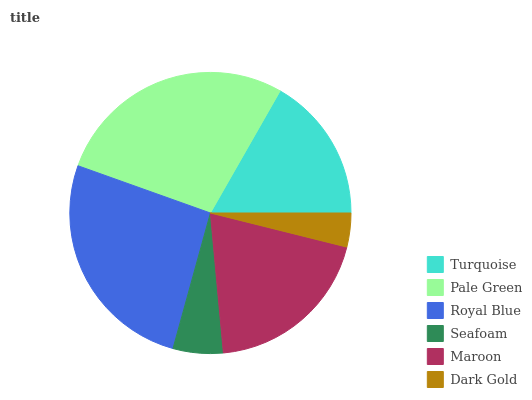Is Dark Gold the minimum?
Answer yes or no. Yes. Is Pale Green the maximum?
Answer yes or no. Yes. Is Royal Blue the minimum?
Answer yes or no. No. Is Royal Blue the maximum?
Answer yes or no. No. Is Pale Green greater than Royal Blue?
Answer yes or no. Yes. Is Royal Blue less than Pale Green?
Answer yes or no. Yes. Is Royal Blue greater than Pale Green?
Answer yes or no. No. Is Pale Green less than Royal Blue?
Answer yes or no. No. Is Maroon the high median?
Answer yes or no. Yes. Is Turquoise the low median?
Answer yes or no. Yes. Is Dark Gold the high median?
Answer yes or no. No. Is Maroon the low median?
Answer yes or no. No. 